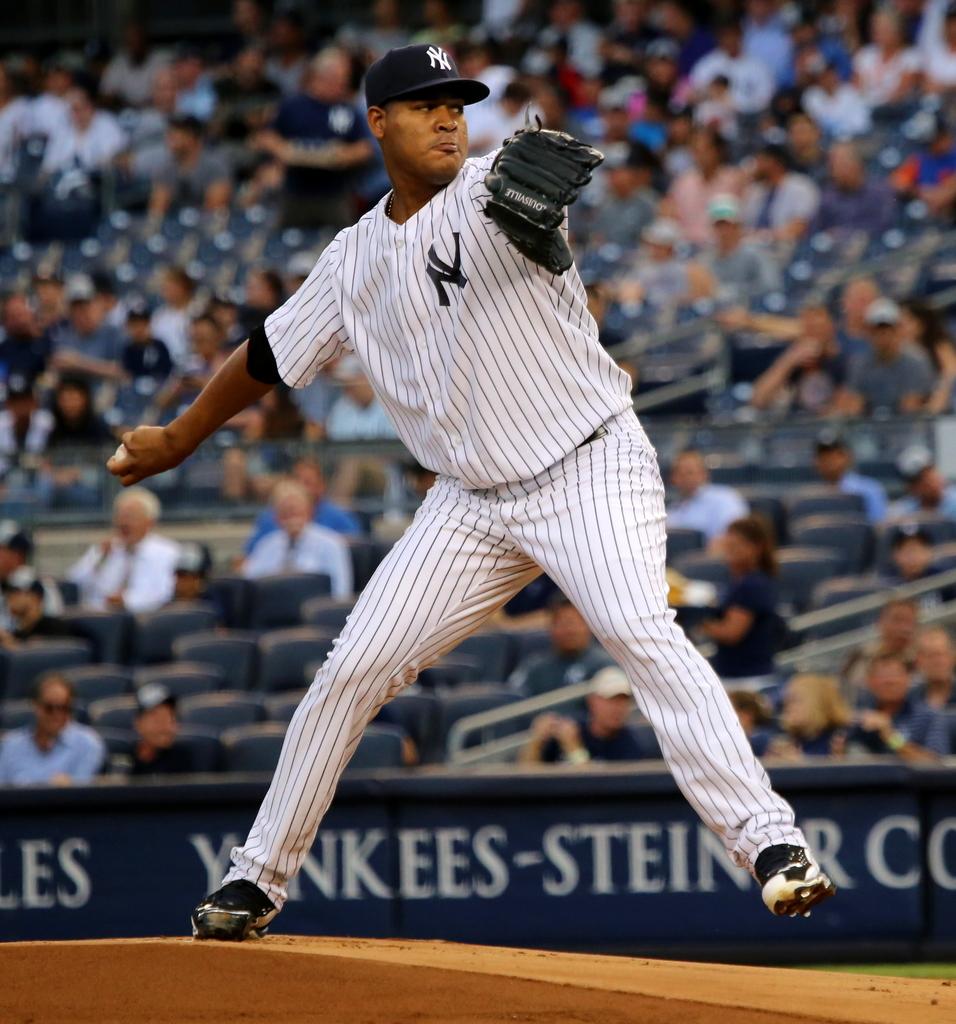Is this part of the yankees?
Give a very brief answer. Yes. What name is on the jersey?
Offer a very short reply. Ny. 